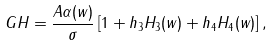<formula> <loc_0><loc_0><loc_500><loc_500>G H = \frac { A \alpha ( w ) } { \sigma } \left [ 1 + h _ { 3 } H _ { 3 } ( w ) + h _ { 4 } H _ { 4 } ( w ) \right ] ,</formula> 